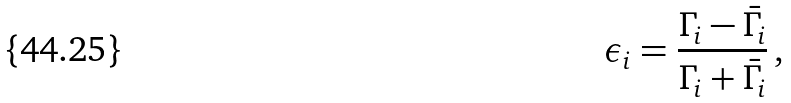Convert formula to latex. <formula><loc_0><loc_0><loc_500><loc_500>\epsilon _ { i } = \frac { \Gamma _ { i } - \bar { \Gamma _ { i } } } { \Gamma _ { i } + \bar { \Gamma _ { i } } } \, ,</formula> 